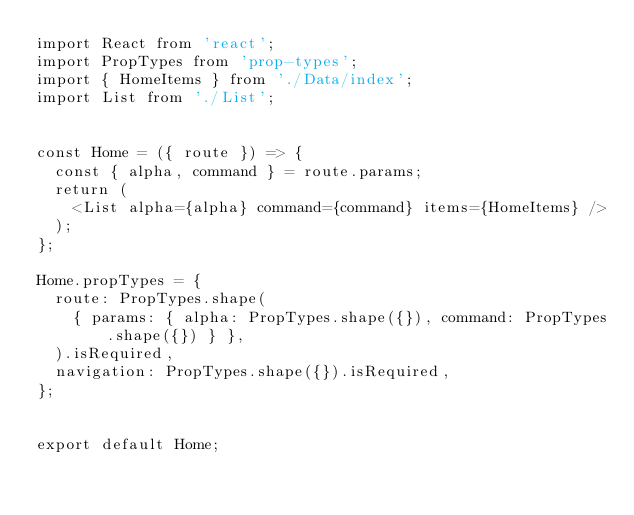Convert code to text. <code><loc_0><loc_0><loc_500><loc_500><_JavaScript_>import React from 'react';
import PropTypes from 'prop-types';
import { HomeItems } from './Data/index';
import List from './List';


const Home = ({ route }) => {
  const { alpha, command } = route.params;
  return (
    <List alpha={alpha} command={command} items={HomeItems} />
  );
};

Home.propTypes = {
  route: PropTypes.shape(
    { params: { alpha: PropTypes.shape({}), command: PropTypes.shape({}) } },
  ).isRequired,
  navigation: PropTypes.shape({}).isRequired,
};


export default Home;
</code> 